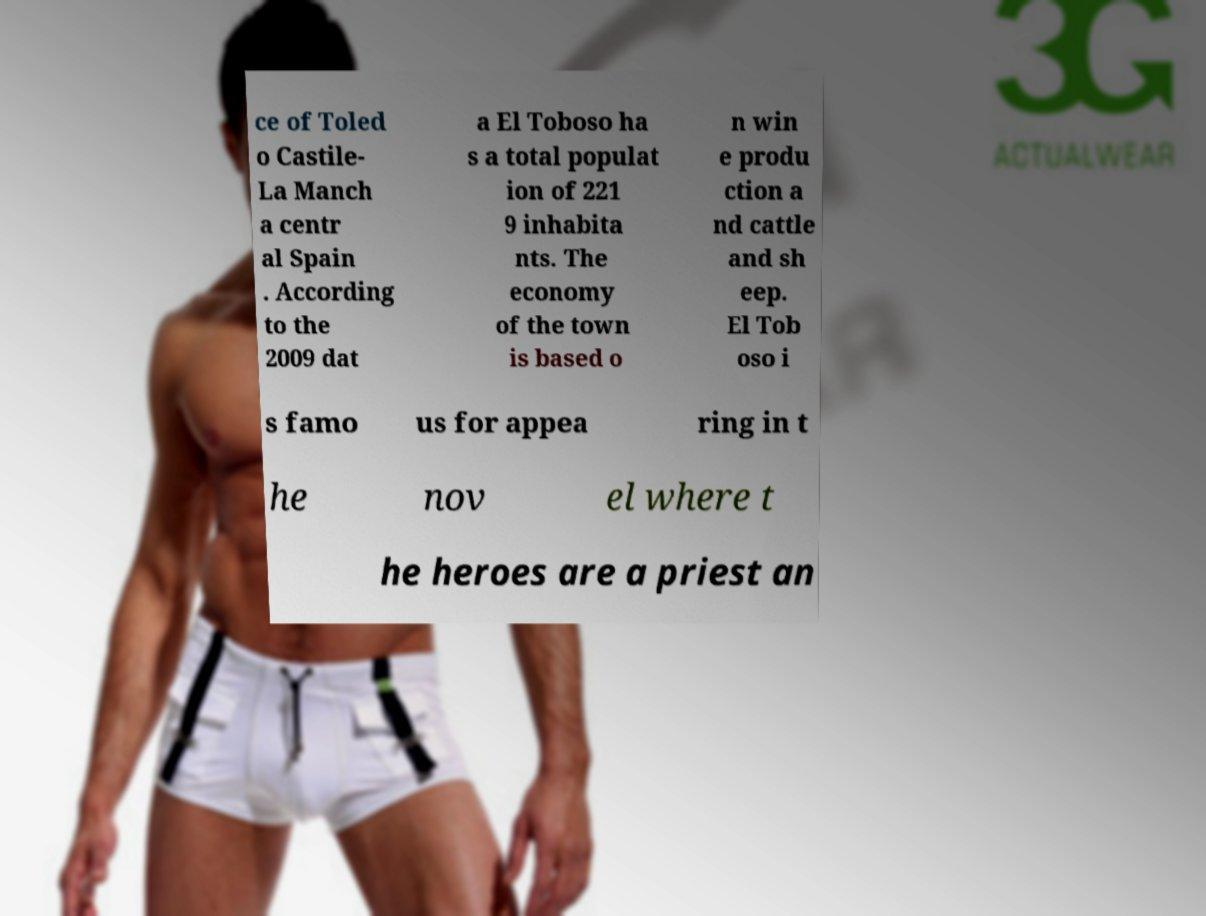For documentation purposes, I need the text within this image transcribed. Could you provide that? ce of Toled o Castile- La Manch a centr al Spain . According to the 2009 dat a El Toboso ha s a total populat ion of 221 9 inhabita nts. The economy of the town is based o n win e produ ction a nd cattle and sh eep. El Tob oso i s famo us for appea ring in t he nov el where t he heroes are a priest an 